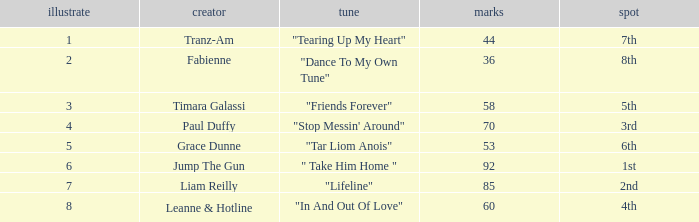What's the average amount of points for "in and out of love" with a draw over 8? None. 